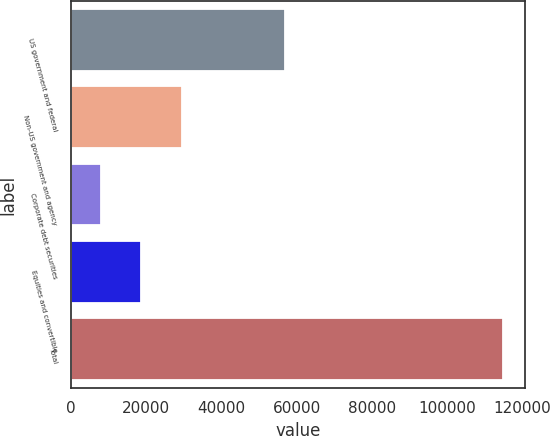<chart> <loc_0><loc_0><loc_500><loc_500><bar_chart><fcel>US government and federal<fcel>Non-US government and agency<fcel>Corporate debt securities<fcel>Equities and convertible<fcel>Total<nl><fcel>56788<fcel>29398.2<fcel>8028<fcel>18713.1<fcel>114879<nl></chart> 